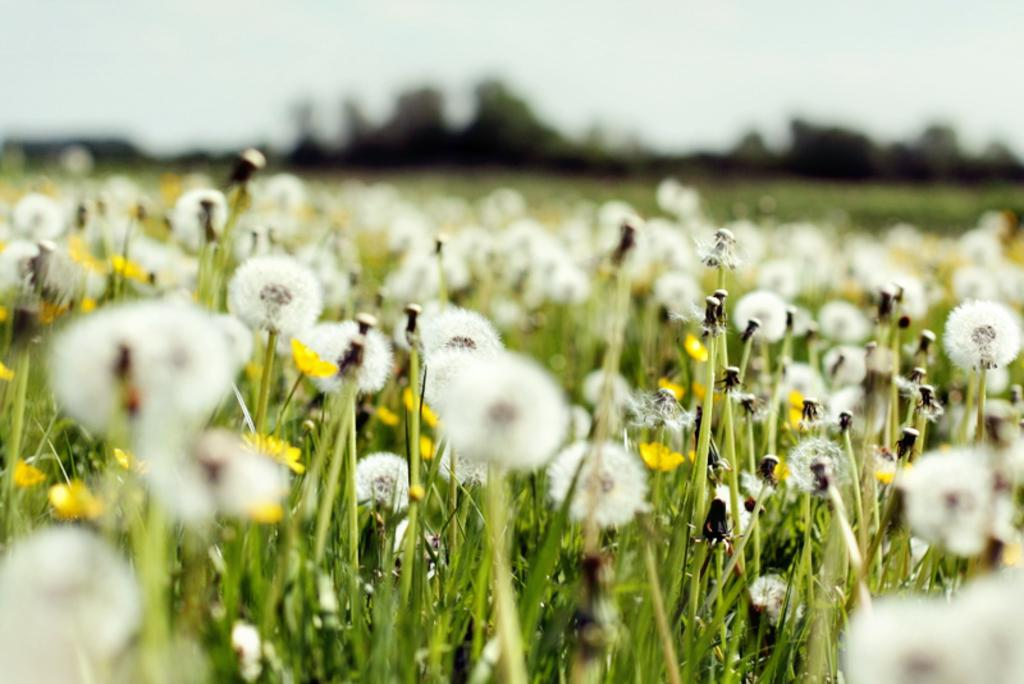What type of plants can be seen in the image? There are flowers in the image. What type of vegetation is at the bottom of the image? There is grass at the bottom of the image. What part of the natural environment is visible in the background of the image? The sky is visible in the background of the image. What type of bun can be seen in the image? There is no bun present in the image. How many toes can be seen in the image? There are no toes visible in the image. 